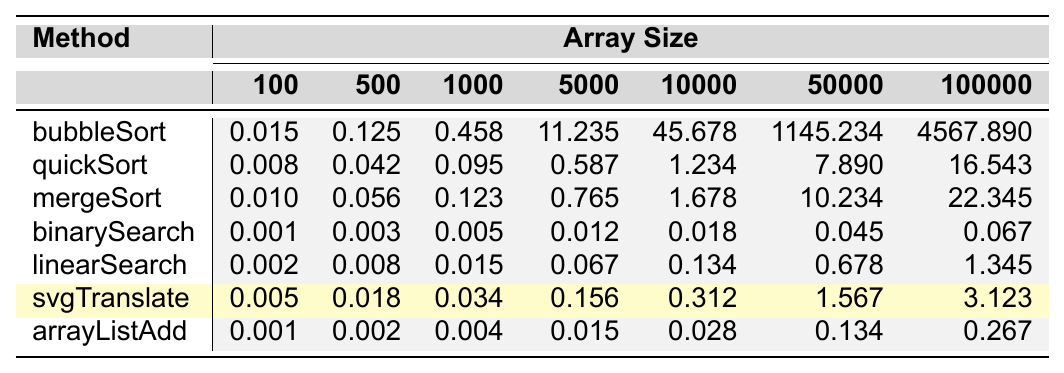What is the execution time of bubbleSort for an array size of 100? Referring to the table, bubbleSort's execution time for an array size of 100 is listed directly, which is 0.015.
Answer: 0.015 Which method has the highest execution time for an array size of 100000? By examining the execution times for the array size of 100000, bubbleSort has the highest execution time of 4567.890 compared to the other methods.
Answer: bubbleSort What is the execution time difference between quickSort and mergeSort for an array size of 5000? We check the execution times for quickSort and mergeSort at an array size of 5000. QuickSort is 0.587 and mergeSort is 0.765. The difference is 0.765 - 0.587 = 0.178.
Answer: 0.178 Is the execution time for binarySearch greater than linearSearch for all array sizes? Comparing the execution times of binarySearch and linearSearch across all array sizes, binarySearch is consistently less than linearSearch for each size, thus the statement is false.
Answer: No What is the average execution time of svgTranslate for all array sizes? The execution times for svgTranslate are collected: 0.005, 0.018, 0.034, 0.156, 0.312, 1.567, 3.123. Summing these gives 5.215, and dividing by 7 (the number of data points) results in an average of approximately 0.745.
Answer: 0.745 What is the relative performance of quickSort compared to bubbleSort for the array size of 1000? For an array size of 1000, quickSort has an execution time of 0.095 while bubbleSort has 0.458. The quickSort is significantly faster than bubbleSort by subtracting the two: 0.458 - 0.095 = 0.363.
Answer: quicker Which method has the lowest execution time for array sizes less than 5000? Looking at execution times for all methods at array sizes of 100, 500, 1000, and 5000, the binarySearch method consistently has the lowest execution time across these sizes.
Answer: binarySearch Calculate the total execution time of all methods for an array size of 10000. The execution times for all methods at 10000 are as follows: bubbleSort (45.678) + quickSort (1.234) + mergeSort (1.678) + binarySearch (0.018) + linearSearch (0.134) + svgTranslate (0.312) + arrayListAdd (0.028) = 48.082.
Answer: 48.082 Does the execution time of mergeSort increase more significantly than bubbleSort as the array size increases? By observing the execution times, bubbleSort shows a much sharper increase compared to mergeSort; for example at 5000, bubbleSort is 11.235, and mergeSort is only 0.765, which indicates bubbleSort increases significantly more than mergeSort.
Answer: No What is the highest execution time recorded for any method in the data? Reviewing the table, bubbleSort's execution time at array size 100000 is the highest at 4567.890.
Answer: 4567.890 